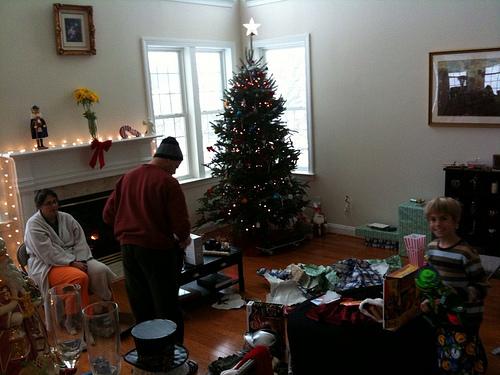Are the people still in their pjs?
Give a very brief answer. Yes. Where are the people sitting?
Concise answer only. Chairs. Did the tree rip up the packages?
Be succinct. No. What holiday is being celebrated?
Write a very short answer. Christmas. 